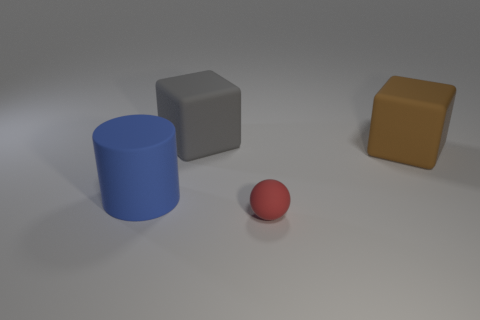There is a matte cube that is in front of the gray rubber thing; is it the same size as the cube on the left side of the brown rubber thing?
Your answer should be very brief. Yes. What size is the rubber block on the left side of the sphere?
Make the answer very short. Large. There is a rubber cube that is in front of the rubber thing behind the large brown rubber cube; what size is it?
Your answer should be compact. Large. There is a blue object that is the same size as the gray thing; what material is it?
Offer a very short reply. Rubber. Are there any small things behind the tiny rubber object?
Your answer should be very brief. No. Are there the same number of large blue matte objects that are left of the cylinder and balls?
Your answer should be very brief. No. What shape is the blue object that is the same size as the gray rubber block?
Your answer should be very brief. Cylinder. What is the material of the blue thing?
Offer a terse response. Rubber. What color is the object that is both in front of the brown rubber object and on the left side of the small object?
Your answer should be compact. Blue. Is the number of brown cubes behind the large gray object the same as the number of gray rubber cubes to the right of the tiny thing?
Ensure brevity in your answer.  Yes. 